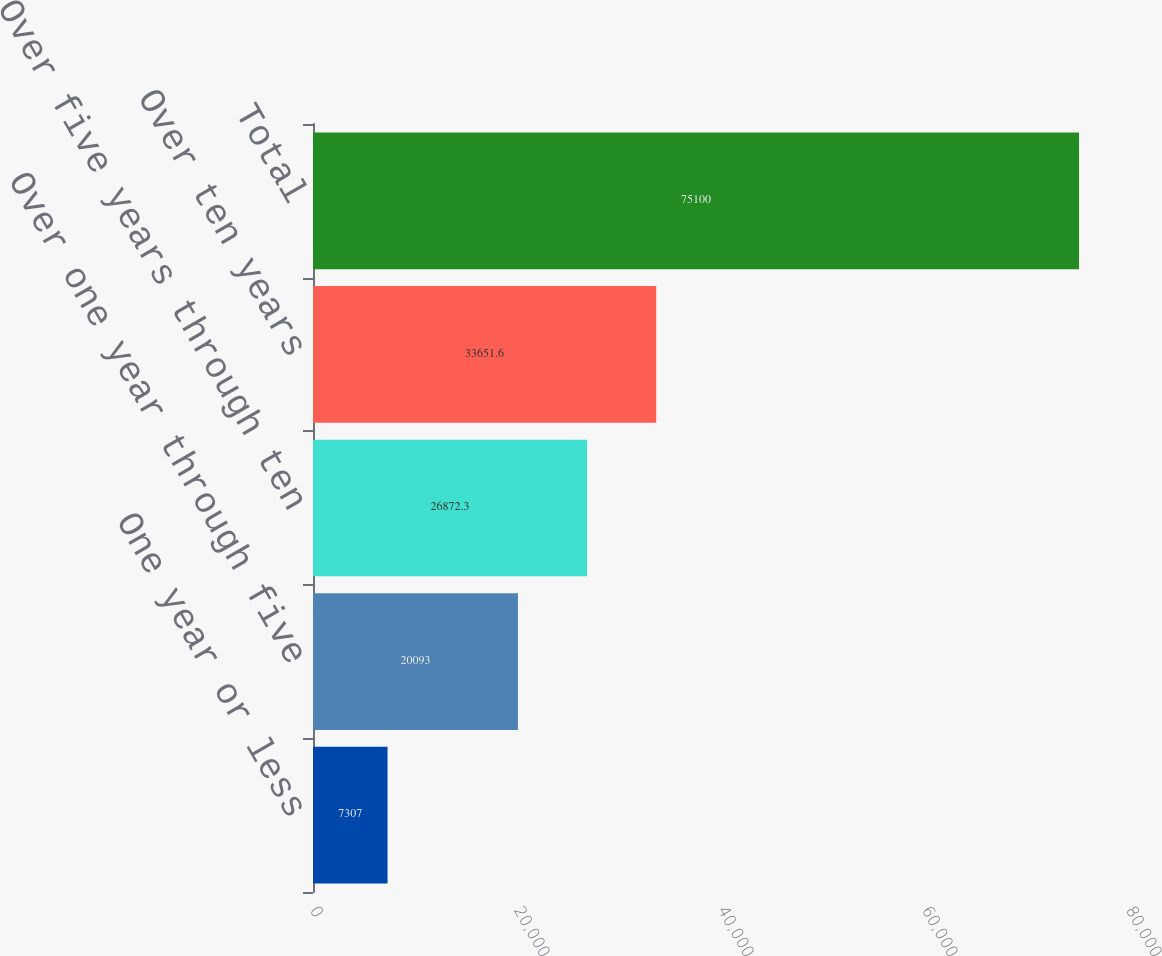Convert chart to OTSL. <chart><loc_0><loc_0><loc_500><loc_500><bar_chart><fcel>One year or less<fcel>Over one year through five<fcel>Over five years through ten<fcel>Over ten years<fcel>Total<nl><fcel>7307<fcel>20093<fcel>26872.3<fcel>33651.6<fcel>75100<nl></chart> 